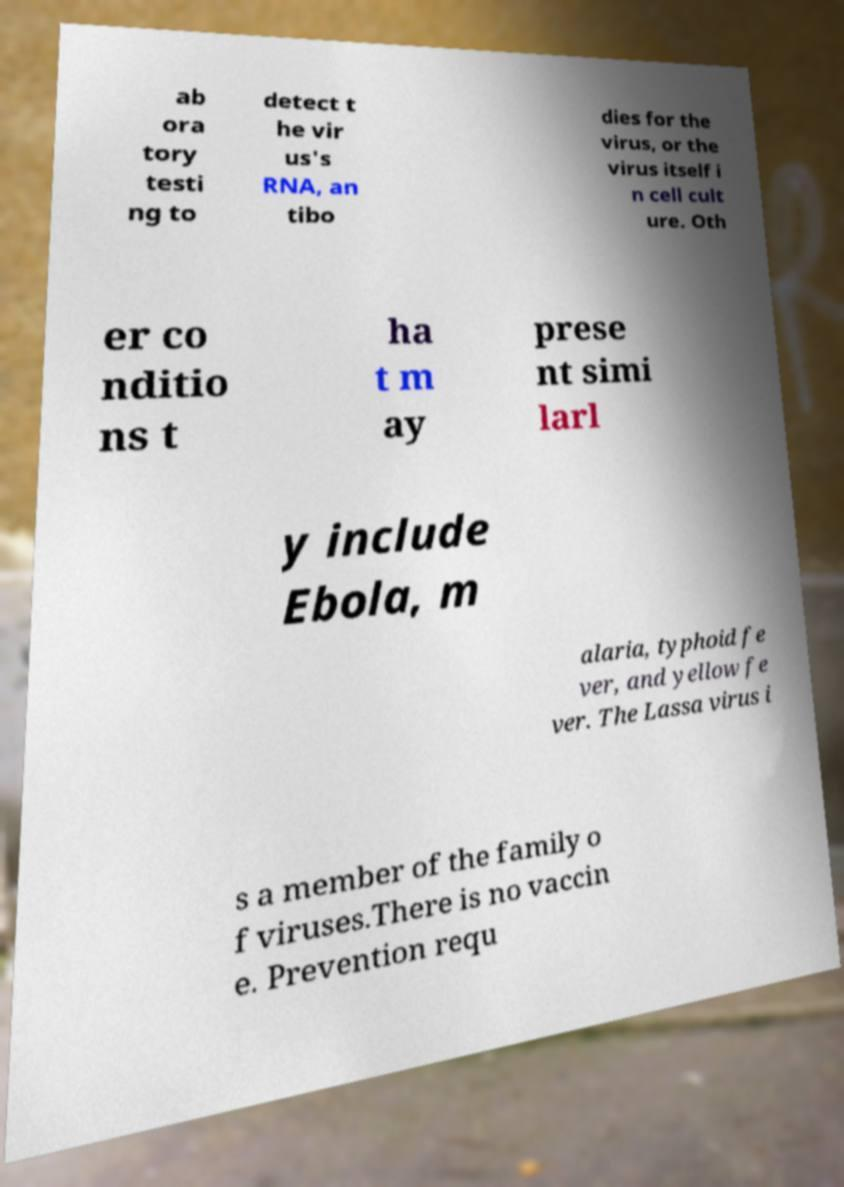Please read and relay the text visible in this image. What does it say? ab ora tory testi ng to detect t he vir us's RNA, an tibo dies for the virus, or the virus itself i n cell cult ure. Oth er co nditio ns t ha t m ay prese nt simi larl y include Ebola, m alaria, typhoid fe ver, and yellow fe ver. The Lassa virus i s a member of the family o f viruses.There is no vaccin e. Prevention requ 